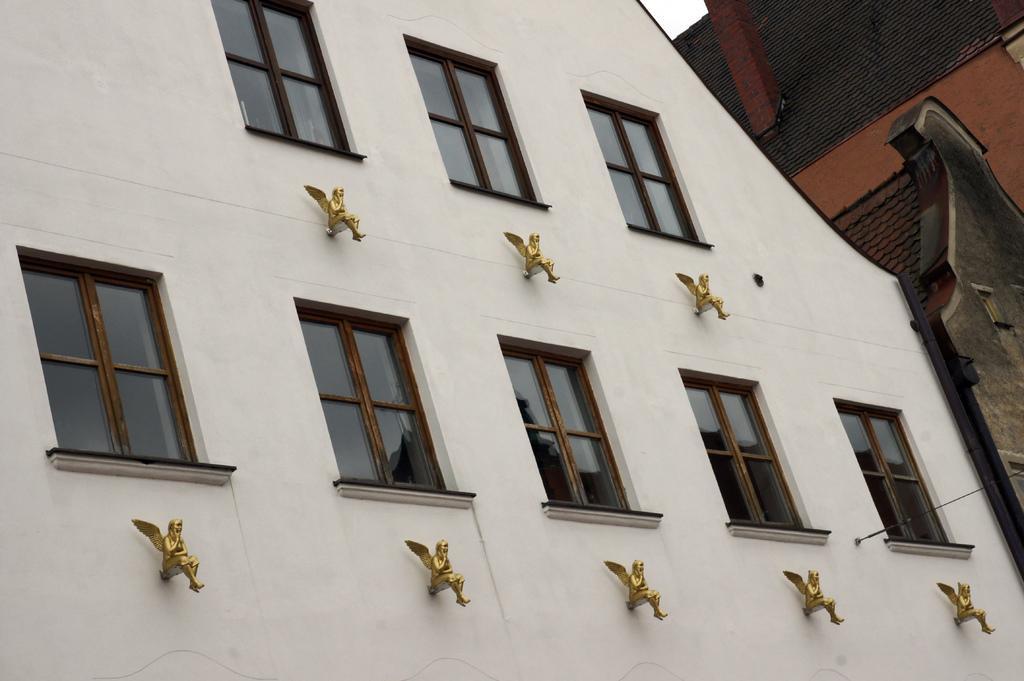Could you give a brief overview of what you see in this image? In the image there is a wall with glass windows and statues. And also there are roofs, chimney and a wall. 